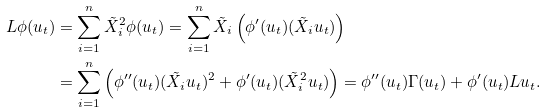<formula> <loc_0><loc_0><loc_500><loc_500>L \phi ( u _ { t } ) & = \sum _ { i = 1 } ^ { n } \tilde { X } _ { i } ^ { 2 } \phi ( u _ { t } ) = \sum _ { i = 1 } ^ { n } \tilde { X } _ { i } \left ( \phi ^ { \prime } ( u _ { t } ) ( \tilde { X } _ { i } u _ { t } ) \right ) \\ & = \sum _ { i = 1 } ^ { n } \left ( \phi ^ { \prime \prime } ( u _ { t } ) ( \tilde { X } _ { i } u _ { t } ) ^ { 2 } + \phi ^ { \prime } ( u _ { t } ) ( \tilde { X } _ { i } ^ { 2 } u _ { t } ) \right ) = \phi ^ { \prime \prime } ( u _ { t } ) \Gamma ( u _ { t } ) + \phi ^ { \prime } ( u _ { t } ) L u _ { t } .</formula> 